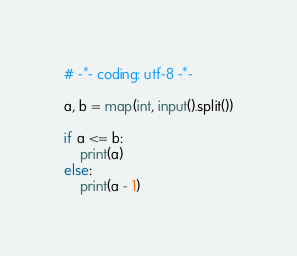<code> <loc_0><loc_0><loc_500><loc_500><_Python_># -*- coding: utf-8 -*-

a, b = map(int, input().split())

if a <= b:
    print(a)
else:
    print(a - 1)</code> 